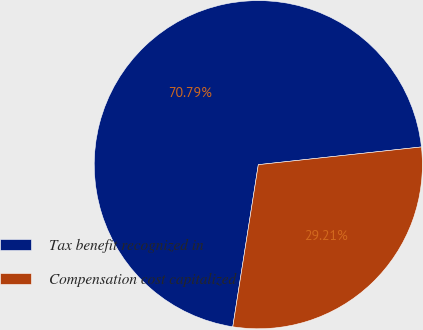<chart> <loc_0><loc_0><loc_500><loc_500><pie_chart><fcel>Tax benefit recognized in<fcel>Compensation cost capitalized<nl><fcel>70.79%<fcel>29.21%<nl></chart> 